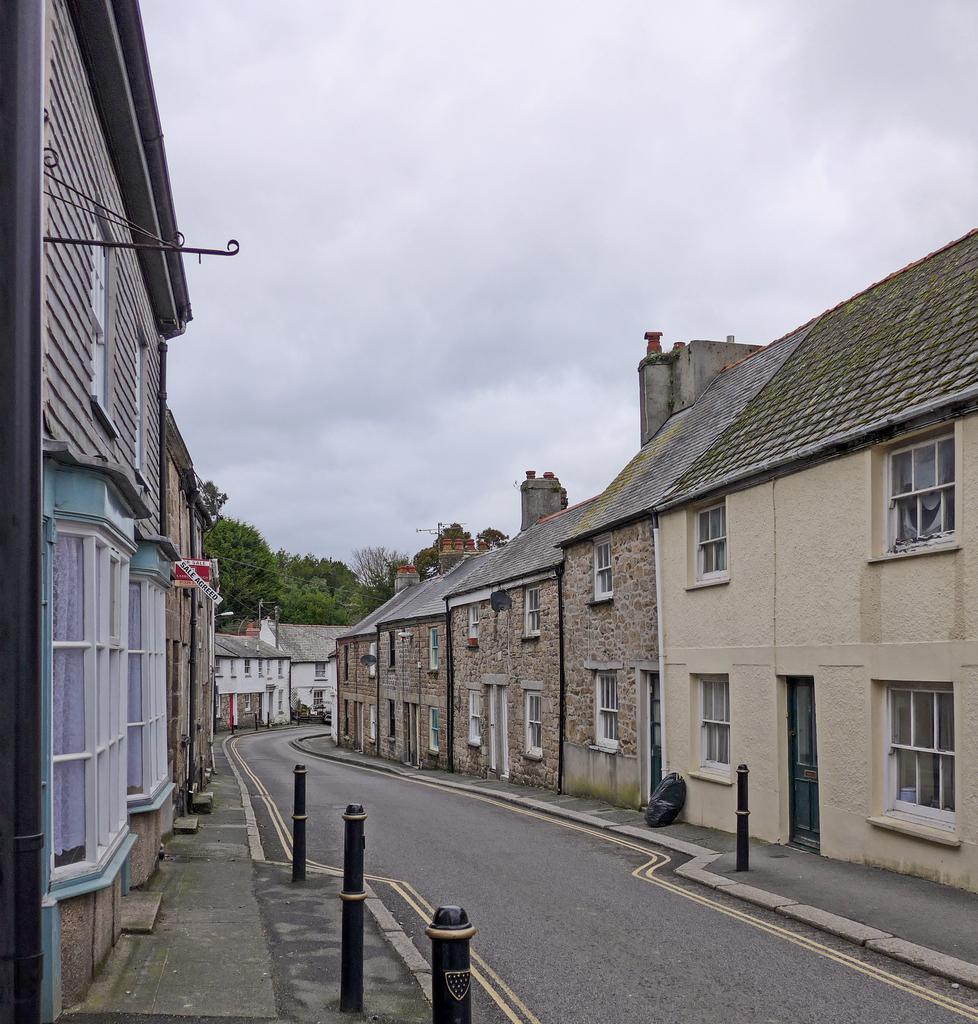What type of structures are present in the image? There are buildings in the image. What colors are the buildings? The buildings are in brown and cream colors. What other objects can be seen in the image? There are poles and trees in the image. What colors are the poles and trees? The poles are in black color, and the trees are in green color. What part of the natural environment is visible in the image? The sky is visible in the image. What color is the sky? The sky is in white color. What type of advertisement can be seen on the buildings in the image? There is no advertisement present on the buildings in the image. How many oranges are hanging from the trees in the image? There are no oranges present in the image; the trees are green. 